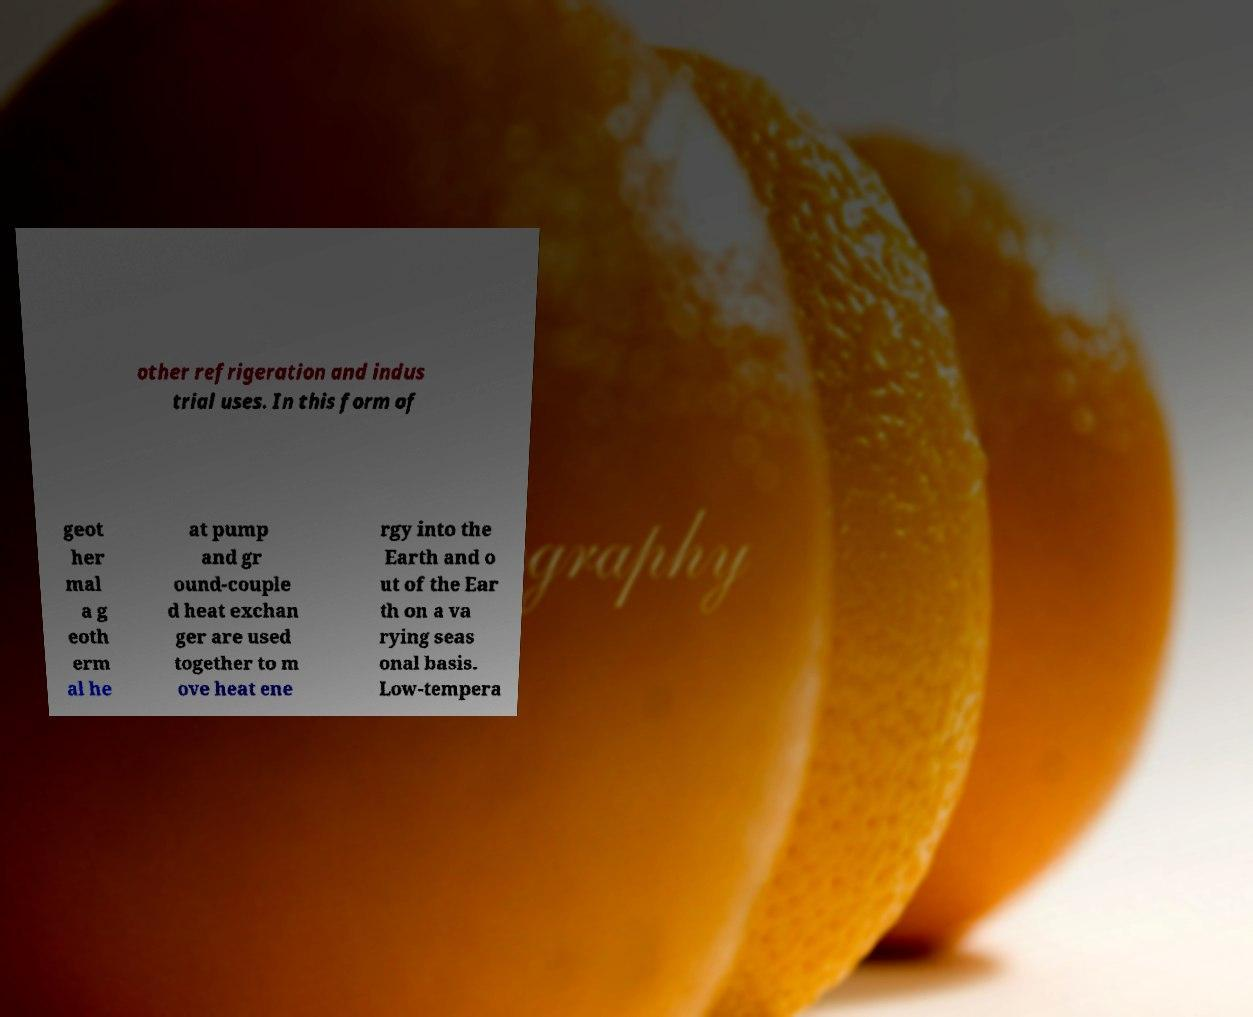Can you read and provide the text displayed in the image?This photo seems to have some interesting text. Can you extract and type it out for me? other refrigeration and indus trial uses. In this form of geot her mal a g eoth erm al he at pump and gr ound-couple d heat exchan ger are used together to m ove heat ene rgy into the Earth and o ut of the Ear th on a va rying seas onal basis. Low-tempera 